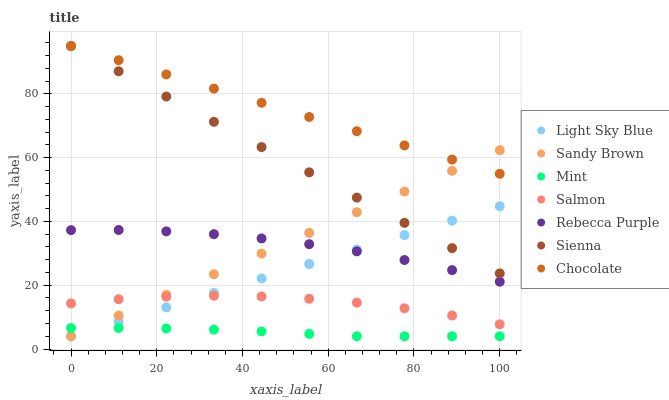Does Mint have the minimum area under the curve?
Answer yes or no. Yes. Does Chocolate have the maximum area under the curve?
Answer yes or no. Yes. Does Salmon have the minimum area under the curve?
Answer yes or no. No. Does Salmon have the maximum area under the curve?
Answer yes or no. No. Is Light Sky Blue the smoothest?
Answer yes or no. Yes. Is Salmon the roughest?
Answer yes or no. Yes. Is Chocolate the smoothest?
Answer yes or no. No. Is Chocolate the roughest?
Answer yes or no. No. Does Sandy Brown have the lowest value?
Answer yes or no. Yes. Does Salmon have the lowest value?
Answer yes or no. No. Does Sienna have the highest value?
Answer yes or no. Yes. Does Salmon have the highest value?
Answer yes or no. No. Is Rebecca Purple less than Chocolate?
Answer yes or no. Yes. Is Chocolate greater than Salmon?
Answer yes or no. Yes. Does Rebecca Purple intersect Sandy Brown?
Answer yes or no. Yes. Is Rebecca Purple less than Sandy Brown?
Answer yes or no. No. Is Rebecca Purple greater than Sandy Brown?
Answer yes or no. No. Does Rebecca Purple intersect Chocolate?
Answer yes or no. No. 